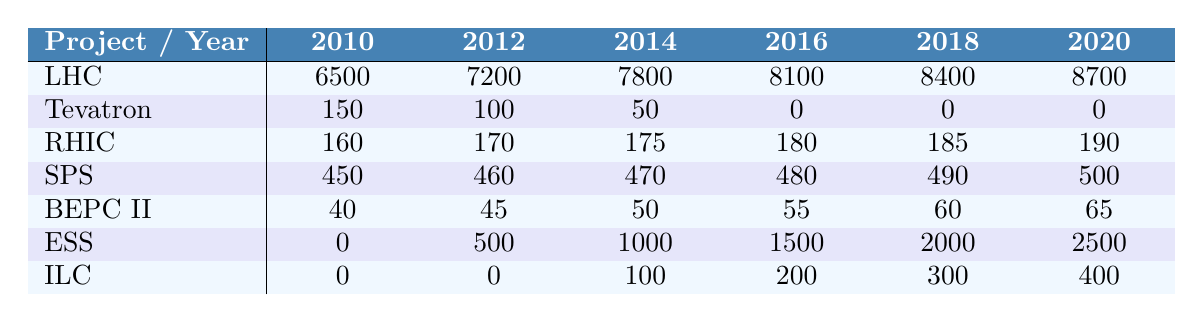What was the funding for the LHC in 2018? The table indicates that the funding for the LHC in 2018 was 8400 million.
Answer: 8400 million Which project had the highest funding in 2020? The funding for each project in 2020 is compared, and the LHC had the highest funding of 8700 million.
Answer: LHC What is the total funding for the Tevatron from 2010 to 2016? The funding amounts for the Tevatron from 2010 to 2016 are 150, 100, 50, 0, 0, and 0. Adding these gives a total of 150 + 100 + 50 + 0 + 0 + 0 = 300 million.
Answer: 300 million Did the funding for the ILC increase every year? The funding for the ILC was 0 in 2010 and 2012, then increased to 100 in 2014, 200 in 2016, 300 in 2018, and 400 in 2020, indicating an increase after 2012 but not every year.
Answer: No What is the average funding per year for the ESS across the years provided? The funding for the ESS from 2010 to 2020 is 0, 500, 1000, 1500, 2000, and 2500. Summing these gives 0 + 500 + 1000 + 1500 + 2000 + 2500 = 6500 million. Dividing by 6 years gives an average of 6500 / 6 ≈ 1083.33 million.
Answer: Approximately 1083.33 million In which year did the SPS reach the funding mark of 490 million? The funding amounts for the SPS in the years listed are 450, 460, 470, 480, 490, and 500, making it clear that the SPS reached 490 million in the year 2018.
Answer: 2018 What was the percentage increase in funding for RHIC from 2014 to 2020? The funding for RHIC in 2014 was 175 million, and in 2020 it was 190 million. The increase is 190 - 175 = 15 million. The percentage increase is (15 / 175) * 100 ≈ 8.57%.
Answer: Approximately 8.57% Which project received no funding over the years from 2010 to 2016? Observing the funding data, the Tevatron has values of 0 for all years from 2016 onwards, and it received no funding starting from 2016.
Answer: Tevatron What is the difference between the funding of BEPC II in 2016 and in 2018? The funding for BEPC II in 2016 was 55 million, and in 2018 it was 60 million. The difference is 60 - 55 = 5 million.
Answer: 5 million Which project had the lowest funding in 2012? Upon reviewing the funding data in 2012, the Tevatron had the least funding amount at 100 million.
Answer: Tevatron 